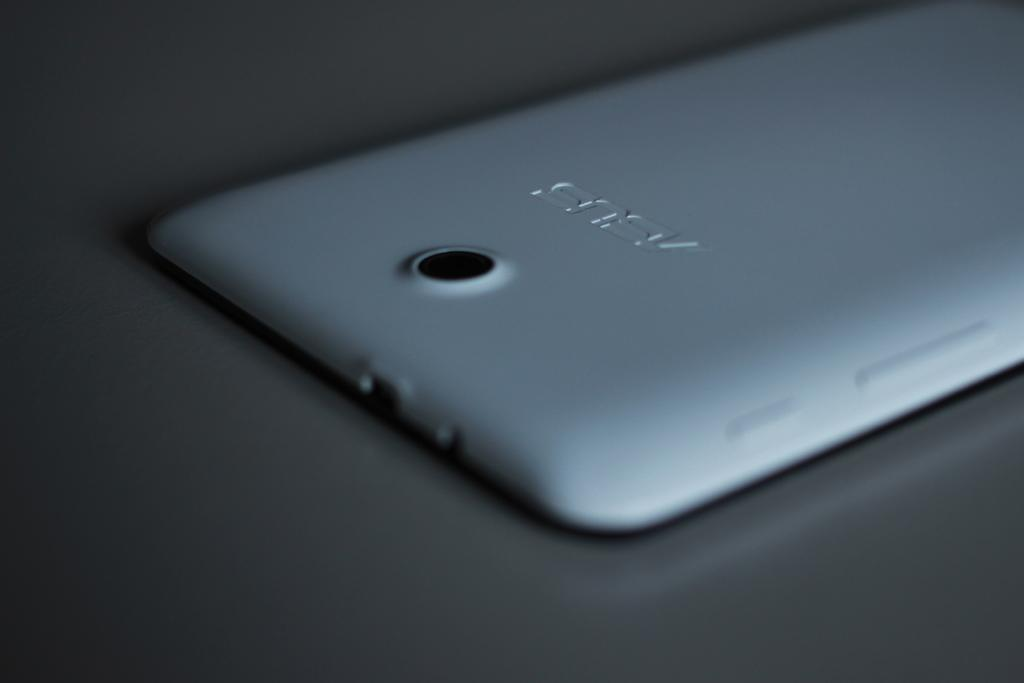<image>
Relay a brief, clear account of the picture shown. the back of an Asus cell phone with camera 